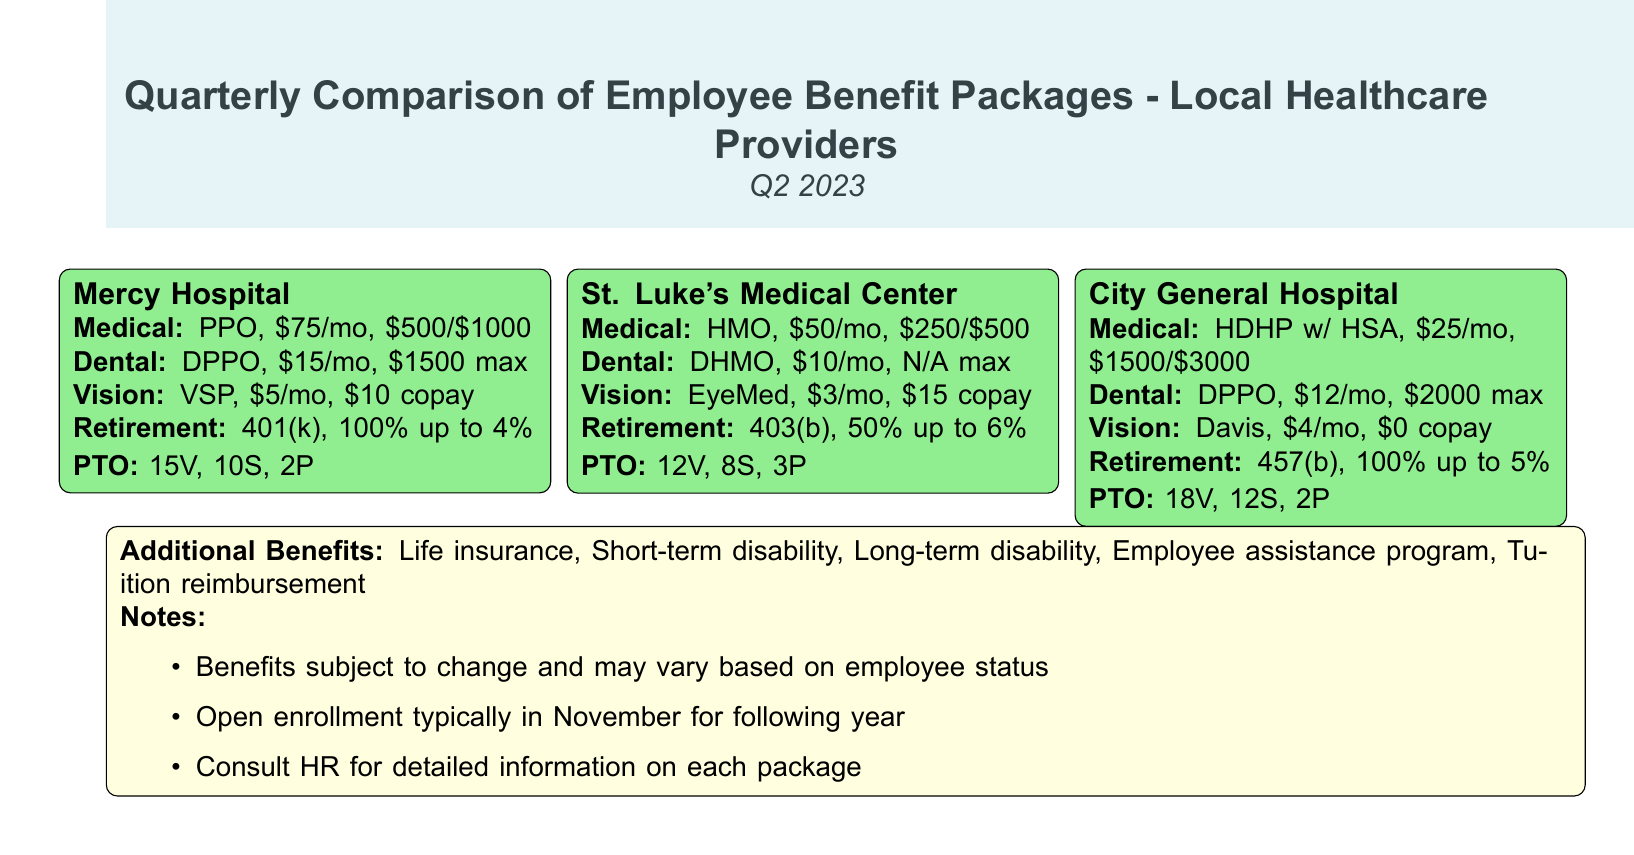What is the medical benefit plan for Mercy Hospital? Mercy Hospital offers a PPO plan for medical benefits at $75 per month with a $500/$1000 deductible.
Answer: PPO, $75/mo, $500/$1000 What is the dental plan offered by St. Luke's Medical Center? St. Luke's Medical Center provides a DHMO plan for dental benefits at $10 per month with no maximum limit.
Answer: DHMO, $10/mo, N/A max What is the vision benefit copay for City General Hospital? City General Hospital has a $0 copay for vision benefits under the Davis plan.
Answer: $0 copay How much does the retirement plan for Mercy Hospital match? Mercy Hospital's retirement plan matches 100% up to 4%.
Answer: 100% up to 4% What is the total amount of PTO for St. Luke's Medical Center? St. Luke's Medical Center provides a total of 23 days PTO, composed of 12 vacation days, 8 sick days, and 3 personal days.
Answer: 12V, 8S, 3P What additional benefits are offered by the healthcare providers? The document lists life insurance, short-term disability, long-term disability, employee assistance program, and tuition reimbursement as additional benefits.
Answer: Life insurance, Short-term disability, Long-term disability, Employee assistance program, Tuition reimbursement When does open enrollment typically occur? Open enrollment typically takes place in November for the following year.
Answer: November What is the max dental benefit for City General Hospital? City General Hospital offers a dental DPPO plan with a maximum benefit of $2000.
Answer: $2000 max What is the monthly cost for vision benefits at St. Luke's Medical Center? St. Luke's Medical Center charges $3 per month for vision benefits with a $15 copay.
Answer: $3/mo, $15 copay 